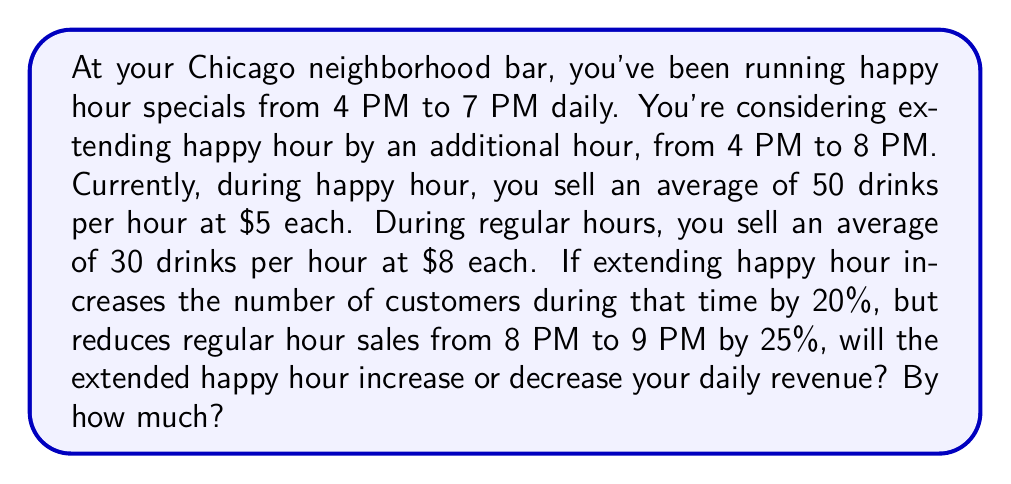Give your solution to this math problem. Let's break this down step-by-step:

1. Calculate current daily revenue:
   - Happy hour (4 PM - 7 PM): $50 \times 5 \times 3 = $750$
   - Regular hours (3 PM - 4 PM, 7 PM - 2 AM): $30 \times 8 \times 8 = $1920$
   - Total current daily revenue: $750 + 1920 = $2670$

2. Calculate new daily revenue with extended happy hour:
   - Extended happy hour (4 PM - 8 PM):
     $50 \times 1.2 \times 5 \times 4 = $1200$
     (20% increase in customers, 4 hours instead of 3)
   - Regular hours (3 PM - 4 PM, 8 PM - 2 AM):
     $30 \times 8 \times 7 = $1680$
     (7 hours instead of 8)
   - Reduced hour (8 PM - 9 PM):
     $30 \times 0.75 \times 8 = $180$
     (25% reduction in sales)
   - Total new daily revenue: $1200 + 1680 + 180 = $3060$

3. Calculate the difference:
   $3060 - 2670 = $390$

Therefore, extending happy hour will increase daily revenue by $390.
Answer: Increase by $390 